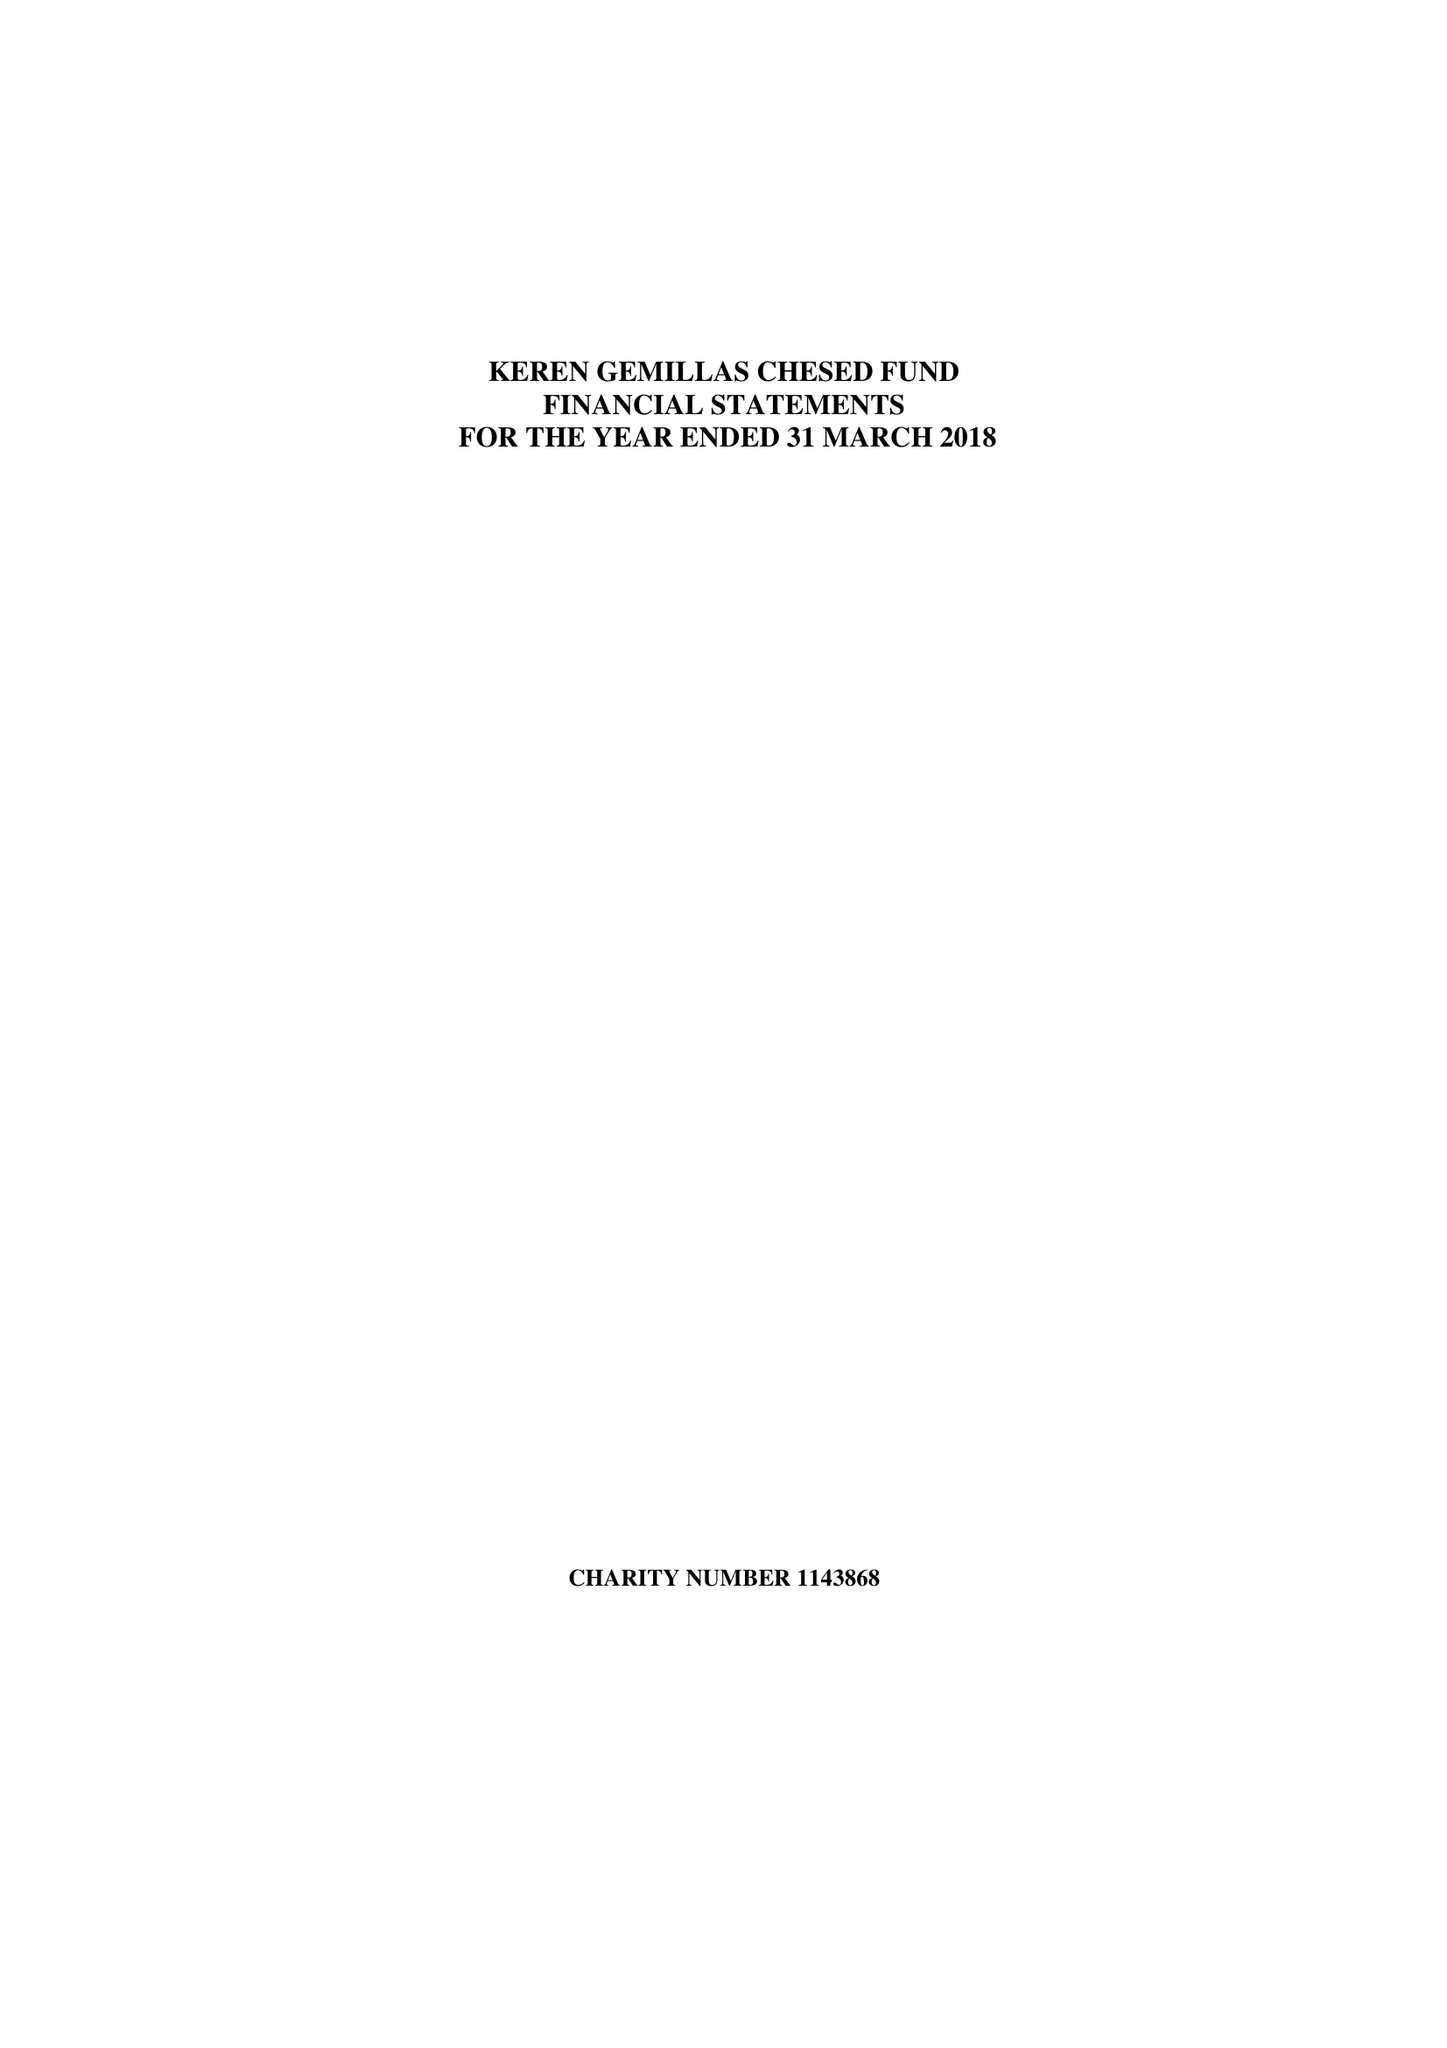What is the value for the address__street_line?
Answer the question using a single word or phrase. None 